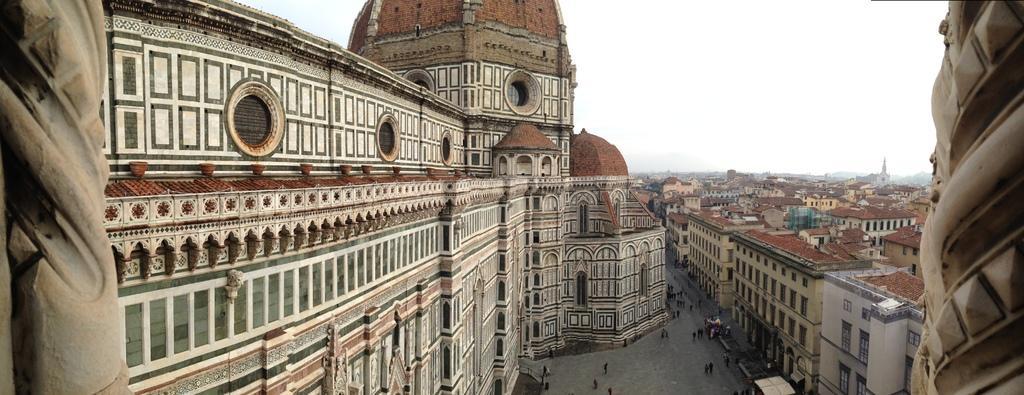Can you describe this image briefly? In this image we can see buildings. There is a road. There are people walking. At the top of the image there is sky. 